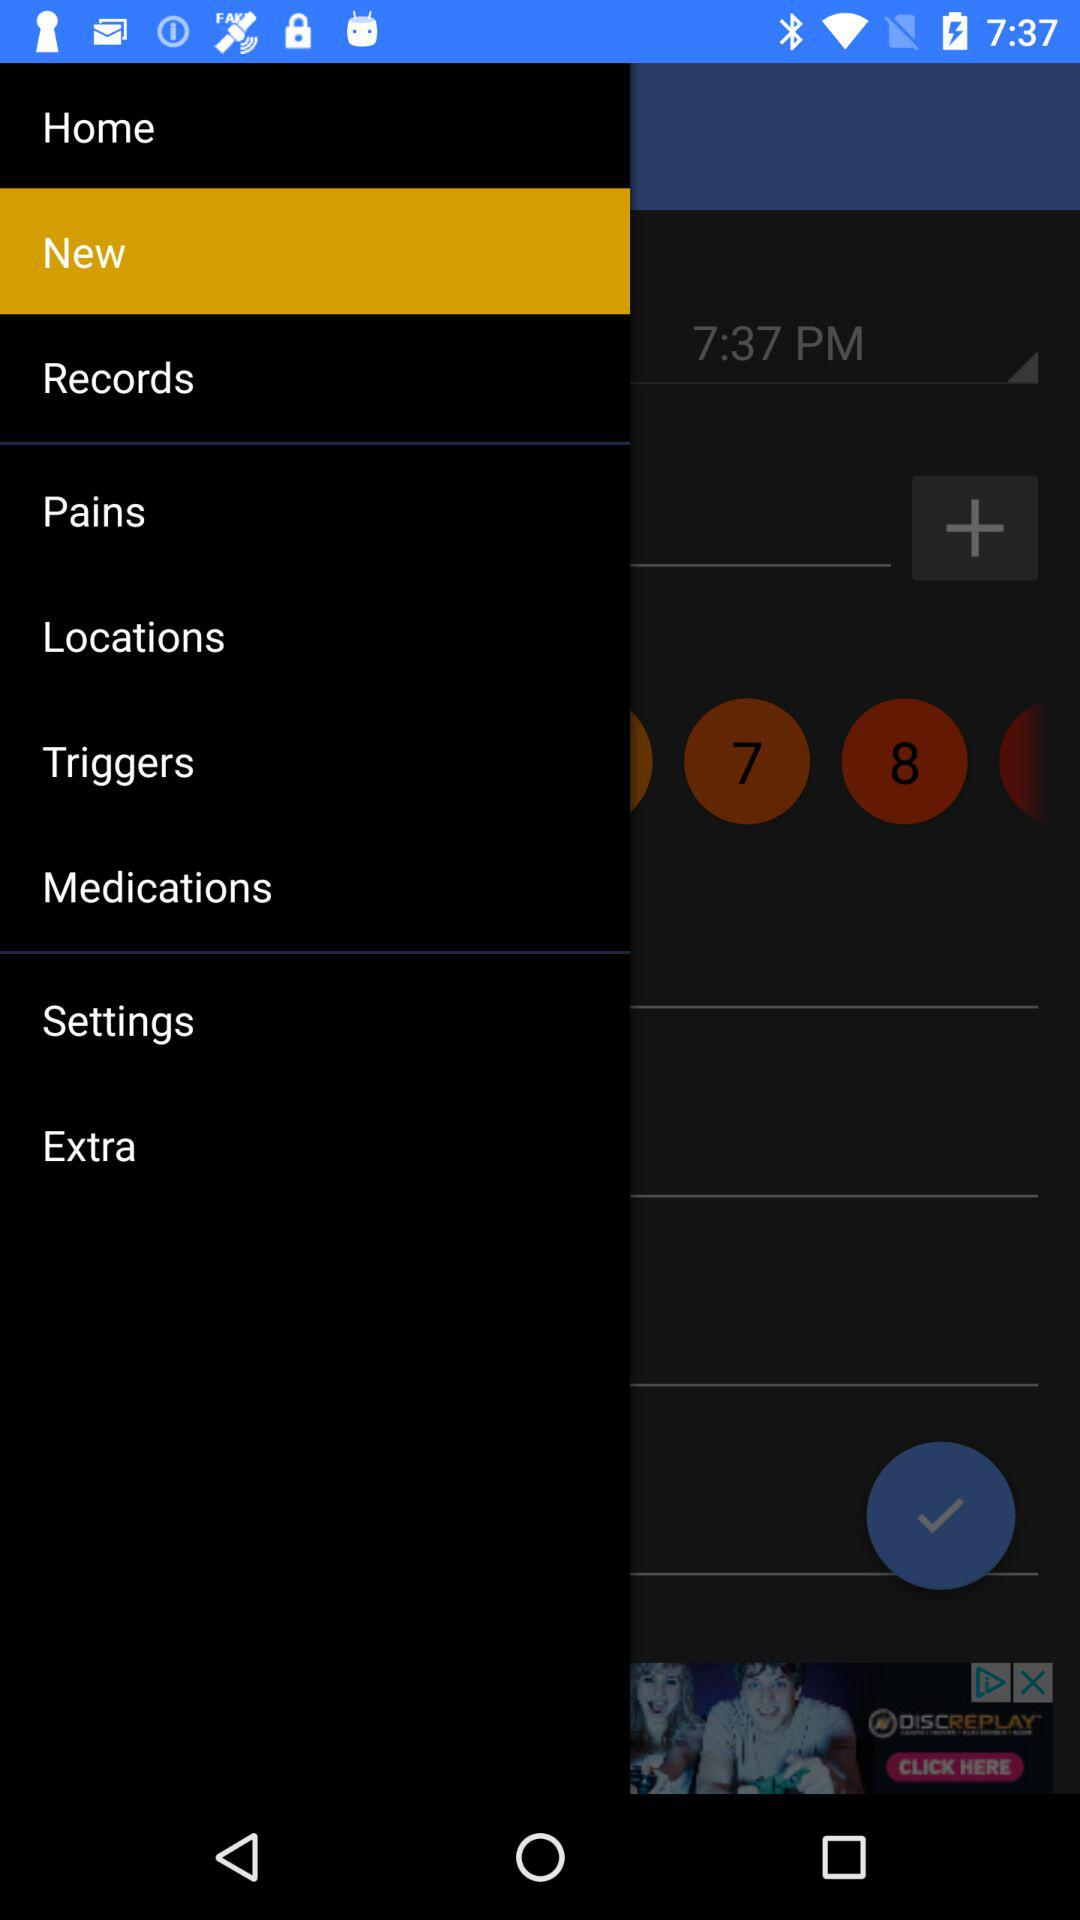Which option is selected? The selected option is "New". 